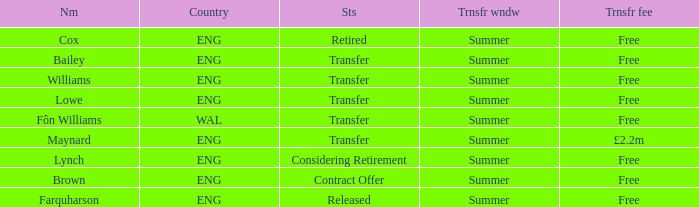What is Brown's transfer window? Summer. 